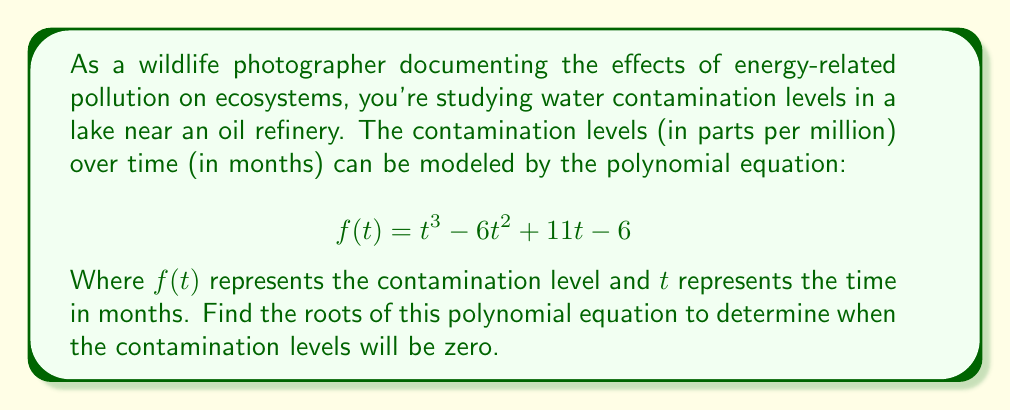Teach me how to tackle this problem. To find the roots of the polynomial equation, we need to factor the polynomial $f(t) = t^3 - 6t^2 + 11t - 6$.

Step 1: Check for rational roots using the rational root theorem.
Possible rational roots: $\pm 1, \pm 2, \pm 3, \pm 6$

Step 2: Use synthetic division to test these roots.
Testing $t = 1$:
$$
\begin{array}{r}
1 \enclose{longdiv}{1 \quad -6 \quad 11 \quad -6} \\
\underline{1 \quad -5 \quad 6} \\
1 \quad -5 \quad 6 \quad 0
\end{array}
$$

We find that $t = 1$ is a root.

Step 3: Factor out $(t - 1)$ from the original polynomial.
$f(t) = (t - 1)(t^2 - 5t + 6)$

Step 4: Use the quadratic formula to solve $t^2 - 5t + 6 = 0$.
$t = \frac{-b \pm \sqrt{b^2 - 4ac}}{2a}$

$t = \frac{5 \pm \sqrt{25 - 24}}{2} = \frac{5 \pm 1}{2}$

$t = 3$ or $t = 2$

Step 5: Write the fully factored polynomial.
$f(t) = (t - 1)(t - 2)(t - 3)$

Therefore, the roots of the polynomial equation are $t = 1$, $t = 2$, and $t = 3$.
Answer: $t = 1, 2, 3$ 